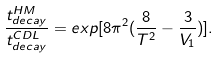Convert formula to latex. <formula><loc_0><loc_0><loc_500><loc_500>\frac { t _ { d e c a y } ^ { H M } } { t _ { d e c a y } ^ { C D L } } = e x p [ 8 \pi ^ { 2 } ( \frac { 8 } { T ^ { 2 } } - \frac { 3 } { V _ { 1 } } ) ] .</formula> 